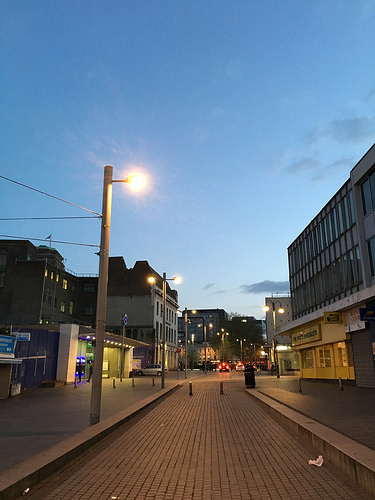<image>
Can you confirm if the light is above the pathway? Yes. The light is positioned above the pathway in the vertical space, higher up in the scene. 